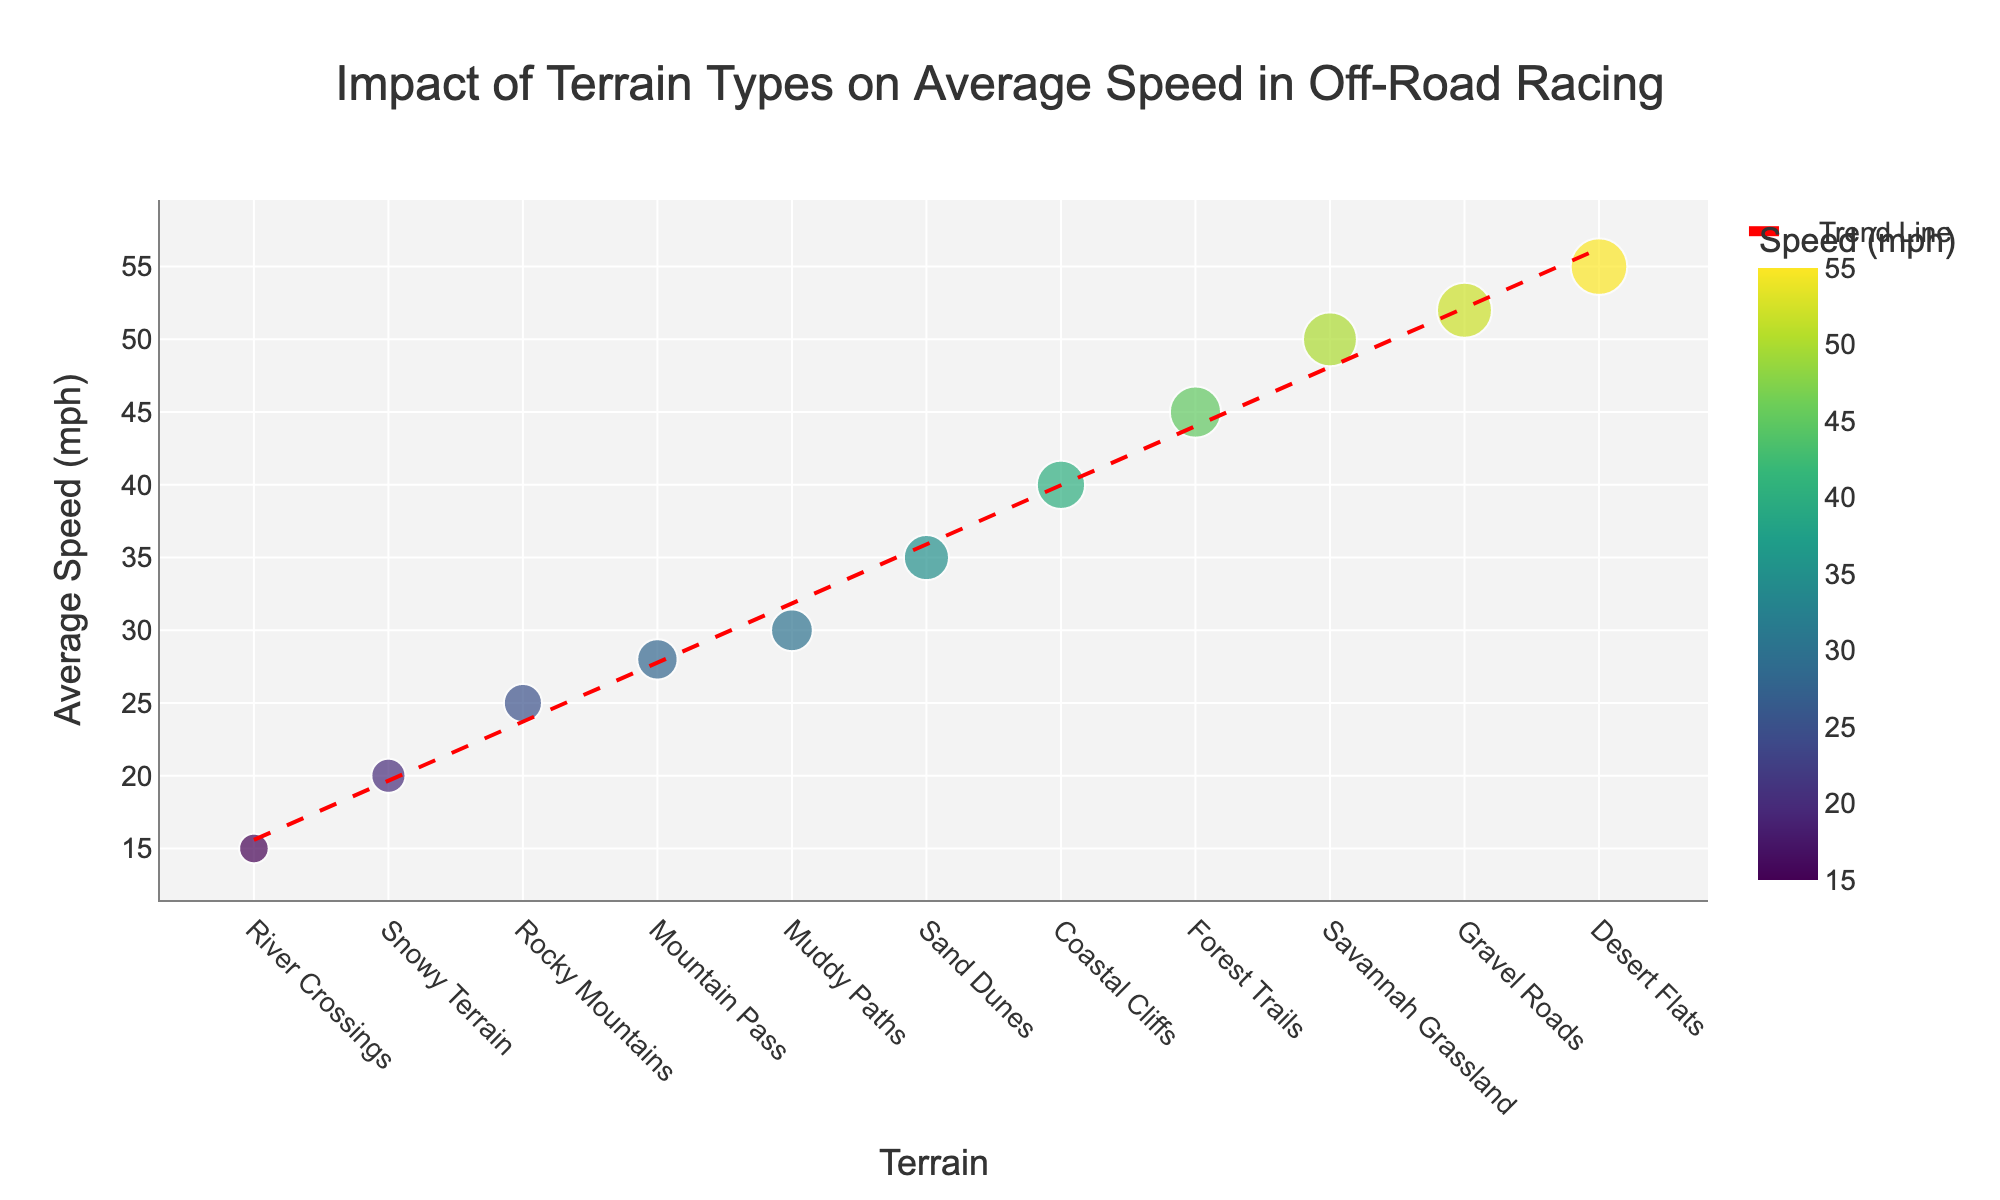Which terrain type has the highest average speed? The figure shows dots representing each terrain type with their respective average speeds. The highest dot indicates the terrain type with the highest average speed.
Answer: Desert Flats What is the title of the plot? The title is displayed at the top of the figure, giving a summarized description of the visualized data.
Answer: Impact of Terrain Types on Average Speed in Off-Road Racing How many terrain types are indicated in the plot? Count the number of unique dots on the scatter plot, each representing a different terrain type.
Answer: 11 What is the average speed for Muddy Paths? Locate the dot labeled "Muddy Paths" and refer to its y-axis value.
Answer: 30 mph Which terrain types have an average speed greater than 50 mph? Identify the dots on the scatter plot whose y-axis value is above 50 mph and note their respective terrain types.
Answer: Desert Flats, Savannah Grassland, Gravel Roads What is the difference in average speed between Gravel Roads and River Crossings? Find the average speeds for Gravel Roads and River Crossings on the y-axis, then subtract the latter from the former. Gravel Roads: 52 mph, River Crossings: 15 mph. Difference: 52 - 15.
Answer: 37 mph How does the average speed trend change across different terrain types? Observe the trend line drawn through the data points to determine the general direction (increasing, decreasing, or stable) across different terrain types.
Answer: Generally decreasing Which terrain type has the lowest average speed? The point closest to the bottom of the y-axis represents the terrain type with the lowest average speed.
Answer: River Crossings Compare the average speeds between Coastal Cliffs and Forest Trails. Which one is faster? Locate the dots for Coastal Cliffs and Forest Trails on the scatter plot and compare their y-axis values.
Answer: Forest Trails Is there a positive or negative trend in the average speeds across the different terrain types? Analyze the slope of the trend line; if it goes downwards, it's a negative trend.
Answer: Negative 